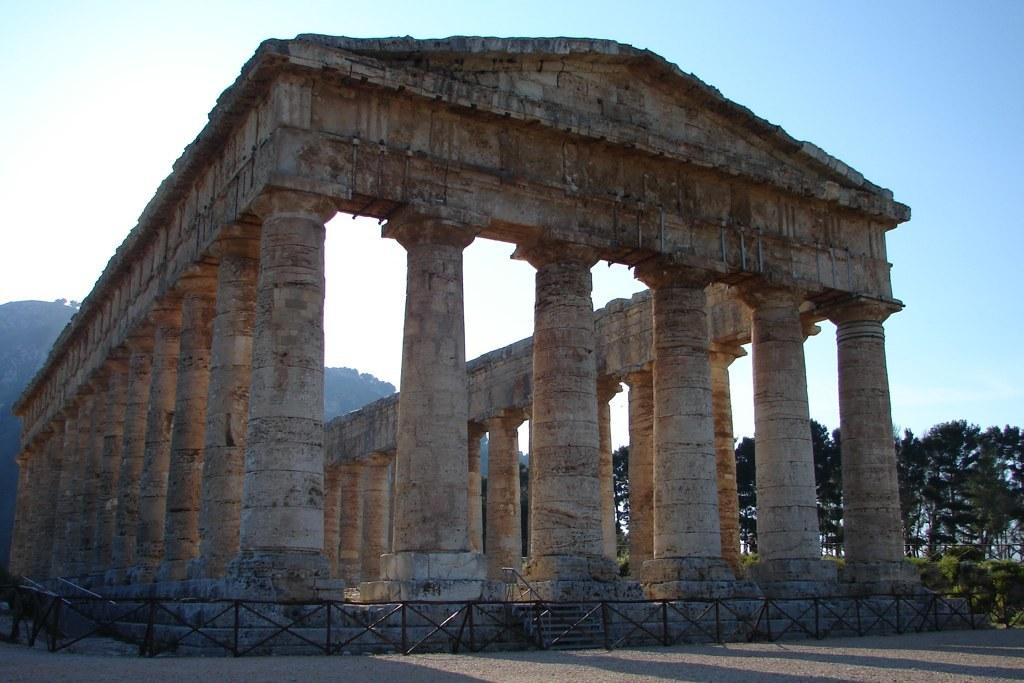What type of structure is depicted in the image? There is an ancient construction in the picture. What surrounds the ancient construction? There is a metal grill fence around the construction. What can be seen on the right side of the image? There are trees on the right side of the image. What is visible in the sky in the image? There are clouds in the sky. How many trucks are parked near the ancient construction in the image? There are no trucks visible in the image; it only features the ancient construction, a metal grill fence, trees, and clouds. What emotion is the group of people feeling near the ancient construction in the image? There are no people present in the image, so it is impossible to determine their emotions. 